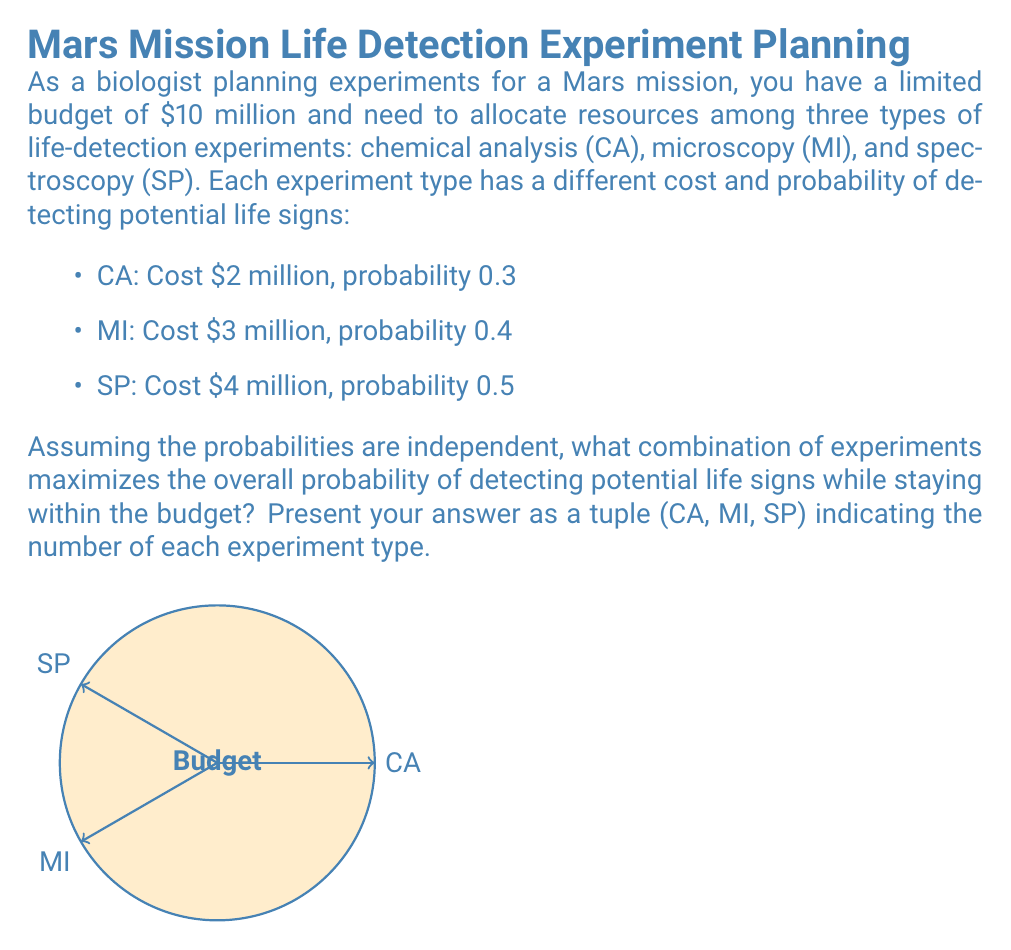Solve this math problem. To solve this optimization problem, we'll use the following approach:

1) First, let's define our objective function. We want to maximize the probability of detecting life signs. The probability of not detecting life signs in a single experiment is (1 - p), where p is the probability of detection for that experiment type.

2) For multiple experiments of the same type, the probability of not detecting life signs is (1 - p)^n, where n is the number of experiments.

3) Since we assume independence, the overall probability of not detecting life signs is the product of these probabilities for all experiment types:

   $P(\text{no detection}) = (1-0.3)^{CA} \cdot (1-0.4)^{MI} \cdot (1-0.5)^{SP}$

4) Therefore, the probability of detecting life signs is:

   $P(\text{detection}) = 1 - (1-0.3)^{CA} \cdot (1-0.4)^{MI} \cdot (1-0.5)^{SP}$

5) Our constraint is the budget:

   $2CA + 3MI + 4SP \leq 10$

6) We need to find integer values for CA, MI, and SP that maximize P(detection) while satisfying the budget constraint.

7) Let's enumerate all possible combinations:

   (0,0,2): P = 0.75, Cost = 8
   (0,1,1): P = 0.7, Cost = 7
   (0,2,1): P = 0.82, Cost = 10
   (0,3,0): P = 0.784, Cost = 9
   (1,0,2): P = 0.825, Cost = 10
   (1,1,1): P = 0.79, Cost = 9
   (1,2,0): P = 0.748, Cost = 8
   (2,0,1): P = 0.755, Cost = 8
   (2,1,0): P = 0.664, Cost = 7
   (3,0,1): P = 0.8285, Cost = 10
   (4,1,0): P = 0.7648, Cost = 10
   (5,0,0): P = 0.83193, Cost = 10

8) The combination that maximizes the probability of detection while staying within budget is (5,0,0) with a probability of approximately 0.83193.
Answer: (5,0,0) 